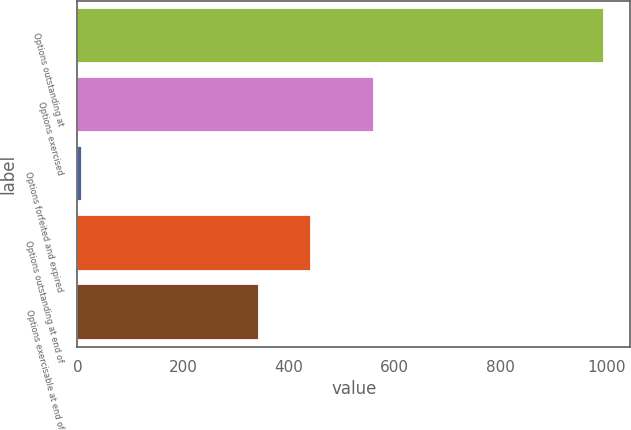Convert chart to OTSL. <chart><loc_0><loc_0><loc_500><loc_500><bar_chart><fcel>Options outstanding at<fcel>Options exercised<fcel>Options forfeited and expired<fcel>Options outstanding at end of<fcel>Options exercisable at end of<nl><fcel>995<fcel>561<fcel>9<fcel>441.6<fcel>343<nl></chart> 